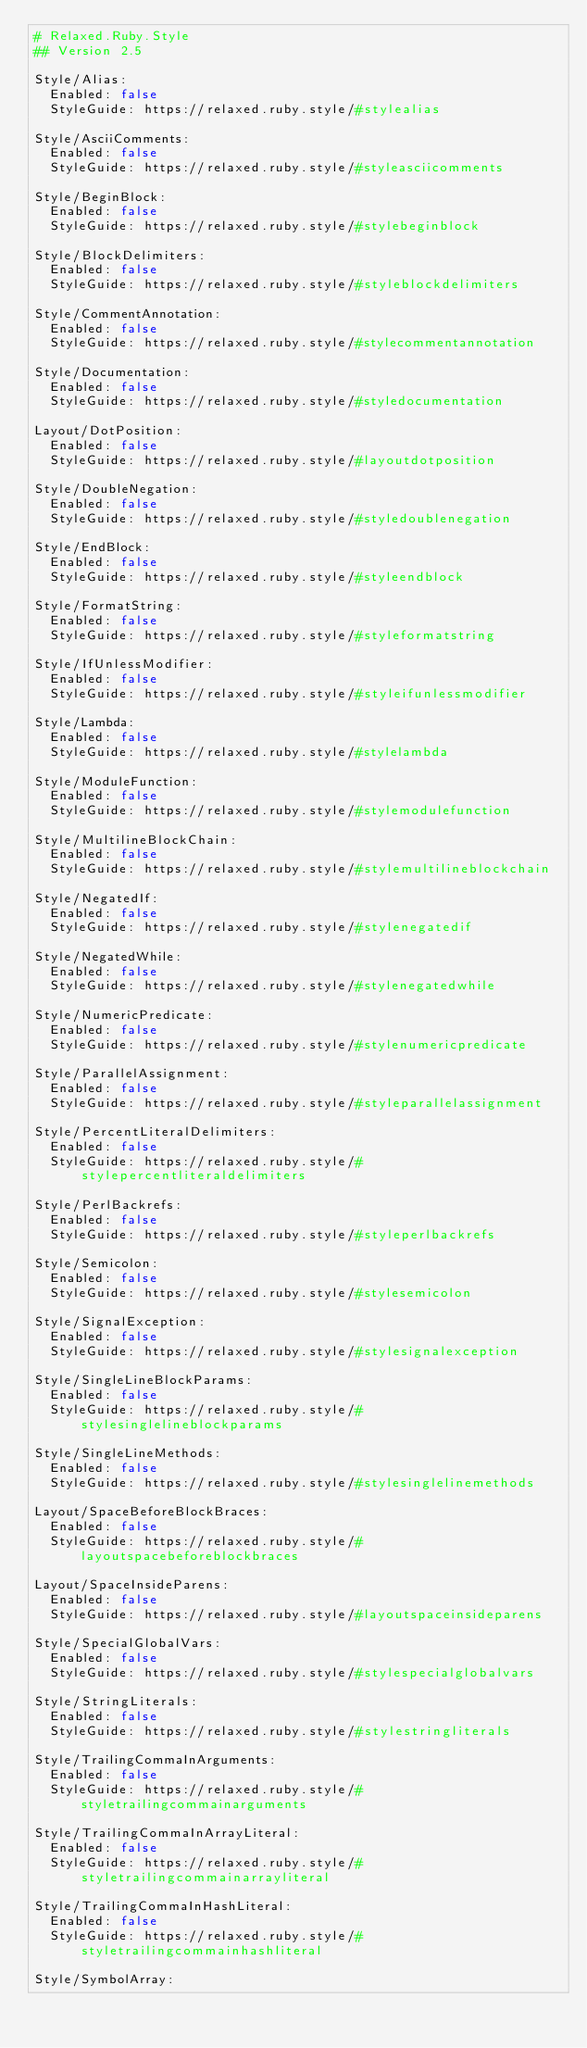Convert code to text. <code><loc_0><loc_0><loc_500><loc_500><_YAML_># Relaxed.Ruby.Style
## Version 2.5

Style/Alias:
  Enabled: false
  StyleGuide: https://relaxed.ruby.style/#stylealias

Style/AsciiComments:
  Enabled: false
  StyleGuide: https://relaxed.ruby.style/#styleasciicomments

Style/BeginBlock:
  Enabled: false
  StyleGuide: https://relaxed.ruby.style/#stylebeginblock

Style/BlockDelimiters:
  Enabled: false
  StyleGuide: https://relaxed.ruby.style/#styleblockdelimiters

Style/CommentAnnotation:
  Enabled: false
  StyleGuide: https://relaxed.ruby.style/#stylecommentannotation

Style/Documentation:
  Enabled: false
  StyleGuide: https://relaxed.ruby.style/#styledocumentation

Layout/DotPosition:
  Enabled: false
  StyleGuide: https://relaxed.ruby.style/#layoutdotposition

Style/DoubleNegation:
  Enabled: false
  StyleGuide: https://relaxed.ruby.style/#styledoublenegation

Style/EndBlock:
  Enabled: false
  StyleGuide: https://relaxed.ruby.style/#styleendblock

Style/FormatString:
  Enabled: false
  StyleGuide: https://relaxed.ruby.style/#styleformatstring

Style/IfUnlessModifier:
  Enabled: false
  StyleGuide: https://relaxed.ruby.style/#styleifunlessmodifier

Style/Lambda:
  Enabled: false
  StyleGuide: https://relaxed.ruby.style/#stylelambda

Style/ModuleFunction:
  Enabled: false
  StyleGuide: https://relaxed.ruby.style/#stylemodulefunction

Style/MultilineBlockChain:
  Enabled: false
  StyleGuide: https://relaxed.ruby.style/#stylemultilineblockchain

Style/NegatedIf:
  Enabled: false
  StyleGuide: https://relaxed.ruby.style/#stylenegatedif

Style/NegatedWhile:
  Enabled: false
  StyleGuide: https://relaxed.ruby.style/#stylenegatedwhile

Style/NumericPredicate:
  Enabled: false
  StyleGuide: https://relaxed.ruby.style/#stylenumericpredicate

Style/ParallelAssignment:
  Enabled: false
  StyleGuide: https://relaxed.ruby.style/#styleparallelassignment

Style/PercentLiteralDelimiters:
  Enabled: false
  StyleGuide: https://relaxed.ruby.style/#stylepercentliteraldelimiters

Style/PerlBackrefs:
  Enabled: false
  StyleGuide: https://relaxed.ruby.style/#styleperlbackrefs

Style/Semicolon:
  Enabled: false
  StyleGuide: https://relaxed.ruby.style/#stylesemicolon

Style/SignalException:
  Enabled: false
  StyleGuide: https://relaxed.ruby.style/#stylesignalexception

Style/SingleLineBlockParams:
  Enabled: false
  StyleGuide: https://relaxed.ruby.style/#stylesinglelineblockparams

Style/SingleLineMethods:
  Enabled: false
  StyleGuide: https://relaxed.ruby.style/#stylesinglelinemethods

Layout/SpaceBeforeBlockBraces:
  Enabled: false
  StyleGuide: https://relaxed.ruby.style/#layoutspacebeforeblockbraces

Layout/SpaceInsideParens:
  Enabled: false
  StyleGuide: https://relaxed.ruby.style/#layoutspaceinsideparens

Style/SpecialGlobalVars:
  Enabled: false
  StyleGuide: https://relaxed.ruby.style/#stylespecialglobalvars

Style/StringLiterals:
  Enabled: false
  StyleGuide: https://relaxed.ruby.style/#stylestringliterals

Style/TrailingCommaInArguments:
  Enabled: false
  StyleGuide: https://relaxed.ruby.style/#styletrailingcommainarguments

Style/TrailingCommaInArrayLiteral:
  Enabled: false
  StyleGuide: https://relaxed.ruby.style/#styletrailingcommainarrayliteral

Style/TrailingCommaInHashLiteral:
  Enabled: false
  StyleGuide: https://relaxed.ruby.style/#styletrailingcommainhashliteral

Style/SymbolArray:</code> 